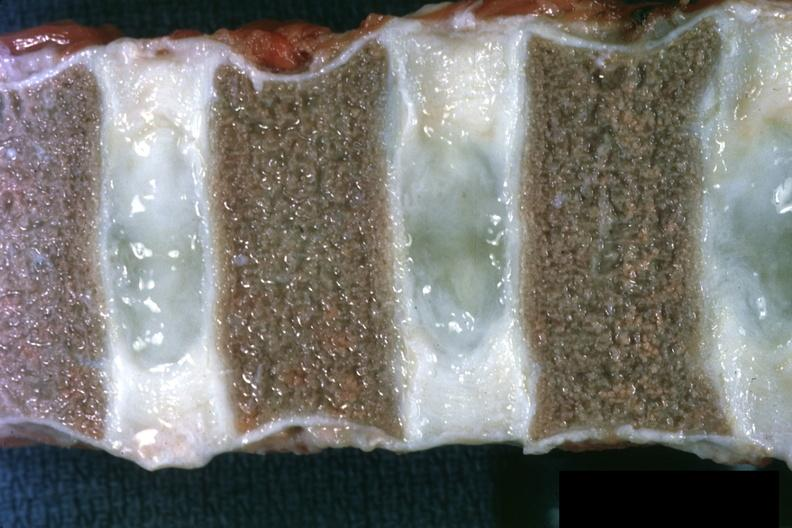what are well shown and normal?
Answer the question using a single word or phrase. Not too spectacular discs 